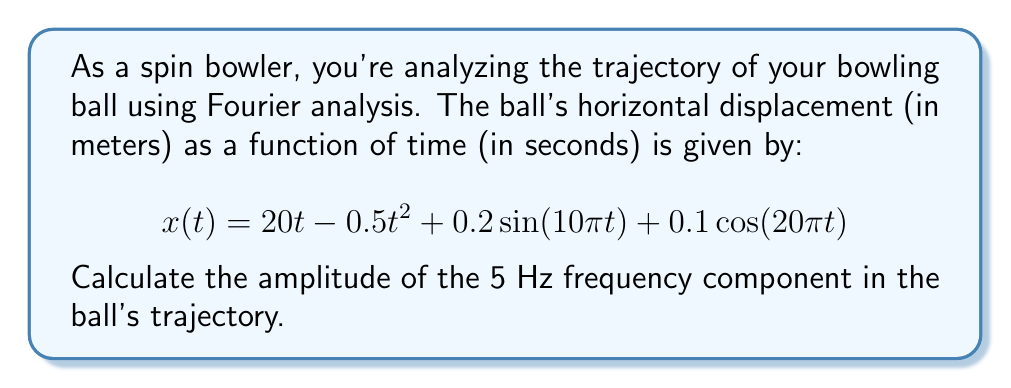Can you solve this math problem? To solve this problem, we need to follow these steps:

1) First, we need to identify the Fourier components in the given function. The sine and cosine terms represent the periodic components:

   $0.2\sin(10\pi t)$ and $0.1\cos(20\pi t)$

2) To find the frequency of each component, we use the formula $f = \omega / (2\pi)$, where $\omega$ is the angular frequency:

   For $\sin(10\pi t)$: $f = 10\pi / (2\pi) = 5$ Hz
   For $\cos(20\pi t)$: $f = 20\pi / (2\pi) = 10$ Hz

3) We're asked about the 5 Hz component, which corresponds to the $\sin(10\pi t)$ term.

4) The amplitude of this component is the coefficient of the sine term, which is 0.2.

Therefore, the amplitude of the 5 Hz frequency component is 0.2 meters.

Note: The other terms in the equation ($20t$ and $-0.5t^2$) represent non-periodic components of the motion and don't contribute to the Fourier spectrum at specific frequencies.
Answer: 0.2 meters 